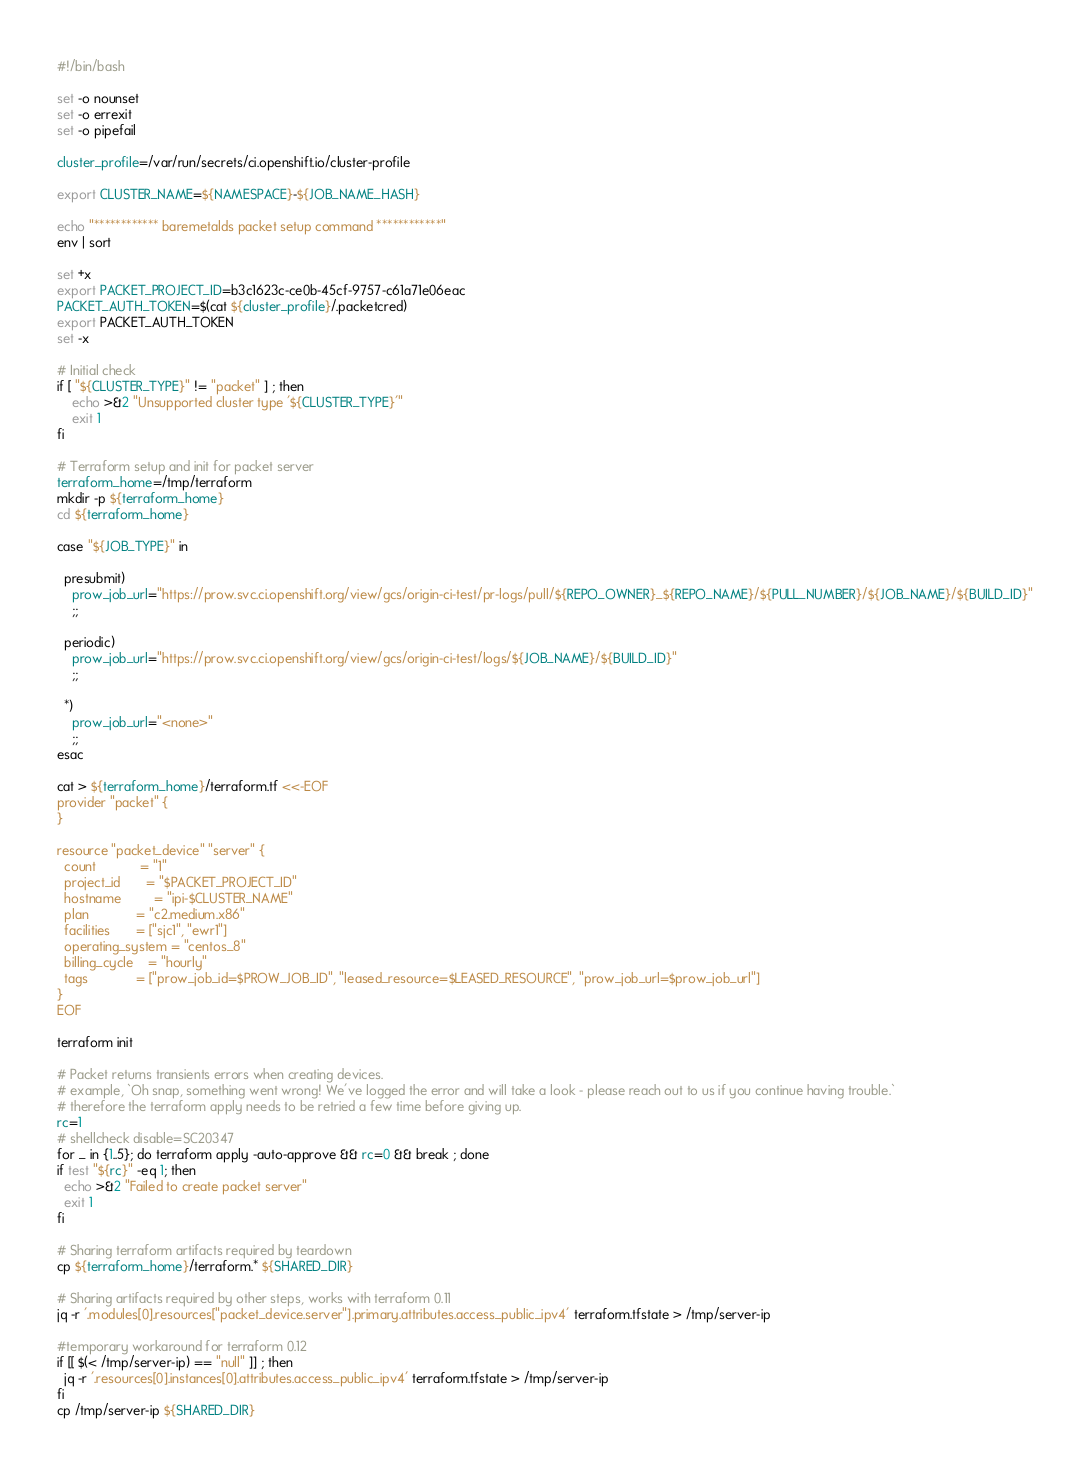Convert code to text. <code><loc_0><loc_0><loc_500><loc_500><_Bash_>#!/bin/bash

set -o nounset
set -o errexit
set -o pipefail

cluster_profile=/var/run/secrets/ci.openshift.io/cluster-profile

export CLUSTER_NAME=${NAMESPACE}-${JOB_NAME_HASH}

echo "************ baremetalds packet setup command ************"
env | sort

set +x
export PACKET_PROJECT_ID=b3c1623c-ce0b-45cf-9757-c61a71e06eac
PACKET_AUTH_TOKEN=$(cat ${cluster_profile}/.packetcred)
export PACKET_AUTH_TOKEN
set -x

# Initial check
if [ "${CLUSTER_TYPE}" != "packet" ] ; then
    echo >&2 "Unsupported cluster type '${CLUSTER_TYPE}'"
    exit 1
fi

# Terraform setup and init for packet server
terraform_home=/tmp/terraform
mkdir -p ${terraform_home}
cd ${terraform_home}

case "${JOB_TYPE}" in 

  presubmit)
    prow_job_url="https://prow.svc.ci.openshift.org/view/gcs/origin-ci-test/pr-logs/pull/${REPO_OWNER}_${REPO_NAME}/${PULL_NUMBER}/${JOB_NAME}/${BUILD_ID}"
    ;;

  periodic)
    prow_job_url="https://prow.svc.ci.openshift.org/view/gcs/origin-ci-test/logs/${JOB_NAME}/${BUILD_ID}"
    ;;

  *)
    prow_job_url="<none>"
    ;;
esac

cat > ${terraform_home}/terraform.tf <<-EOF
provider "packet" {
}

resource "packet_device" "server" {
  count            = "1"
  project_id       = "$PACKET_PROJECT_ID"
  hostname         = "ipi-$CLUSTER_NAME"
  plan             = "c2.medium.x86"
  facilities       = ["sjc1", "ewr1"]
  operating_system = "centos_8"
  billing_cycle    = "hourly"
  tags             = ["prow_job_id=$PROW_JOB_ID", "leased_resource=$LEASED_RESOURCE", "prow_job_url=$prow_job_url"]
}
EOF

terraform init

# Packet returns transients errors when creating devices.
# example, `Oh snap, something went wrong! We've logged the error and will take a look - please reach out to us if you continue having trouble.`
# therefore the terraform apply needs to be retried a few time before giving up.
rc=1
# shellcheck disable=SC20347
for _ in {1..5}; do terraform apply -auto-approve && rc=0 && break ; done
if test "${rc}" -eq 1; then 
  echo >&2 "Failed to create packet server"
  exit 1
fi

# Sharing terraform artifacts required by teardown
cp ${terraform_home}/terraform.* ${SHARED_DIR}

# Sharing artifacts required by other steps, works with terraform 0.11
jq -r '.modules[0].resources["packet_device.server"].primary.attributes.access_public_ipv4' terraform.tfstate > /tmp/server-ip

#temporary workaround for terraform 0.12
if [[ $(< /tmp/server-ip) == "null" ]] ; then
  jq -r '.resources[0].instances[0].attributes.access_public_ipv4' terraform.tfstate > /tmp/server-ip
fi
cp /tmp/server-ip ${SHARED_DIR}



</code> 